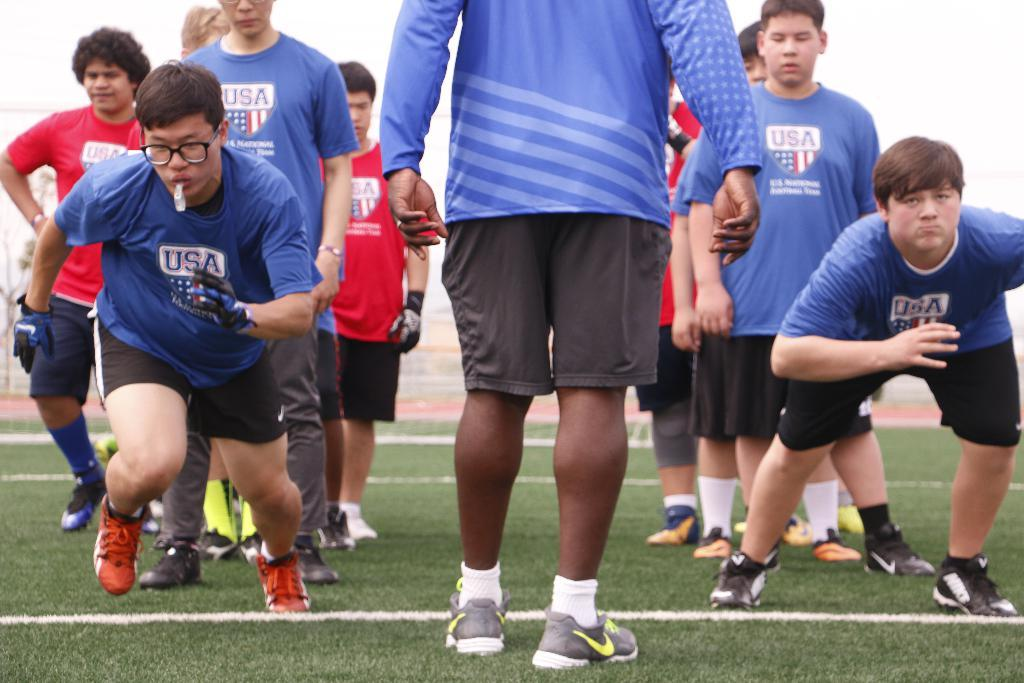How many people are in the image? There is a group of people in the image, but the exact number is not specified. What type of terrain is visible in the image? There is grass visible in the image. What can be seen in the background of the image? The sky is visible in the background of the image. How many fish can be seen swimming in the grass in the image? There are no fish visible in the image, as it features a group of people and grass. 